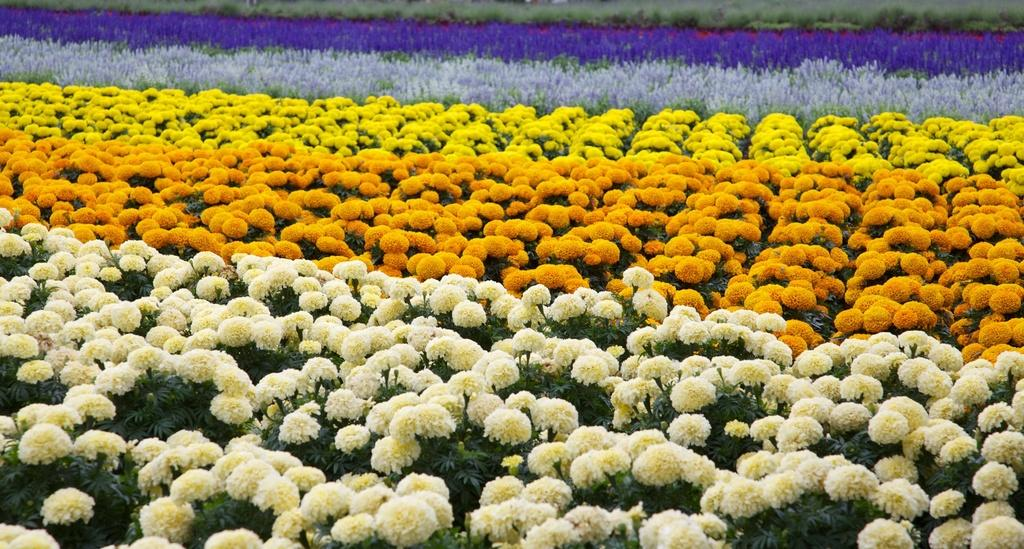What colors of flowers can be seen on the plants in the image? There are white, orange, yellow, and violet flowers on the plants in the image. Can you describe the variety of flowers present? The flowers come in four different colors: white, orange, yellow, and violet. What type of notebook is being used to write a statement about the fan in the image? There is no notebook, statement, or fan present in the image; it only features plants with flowers. 